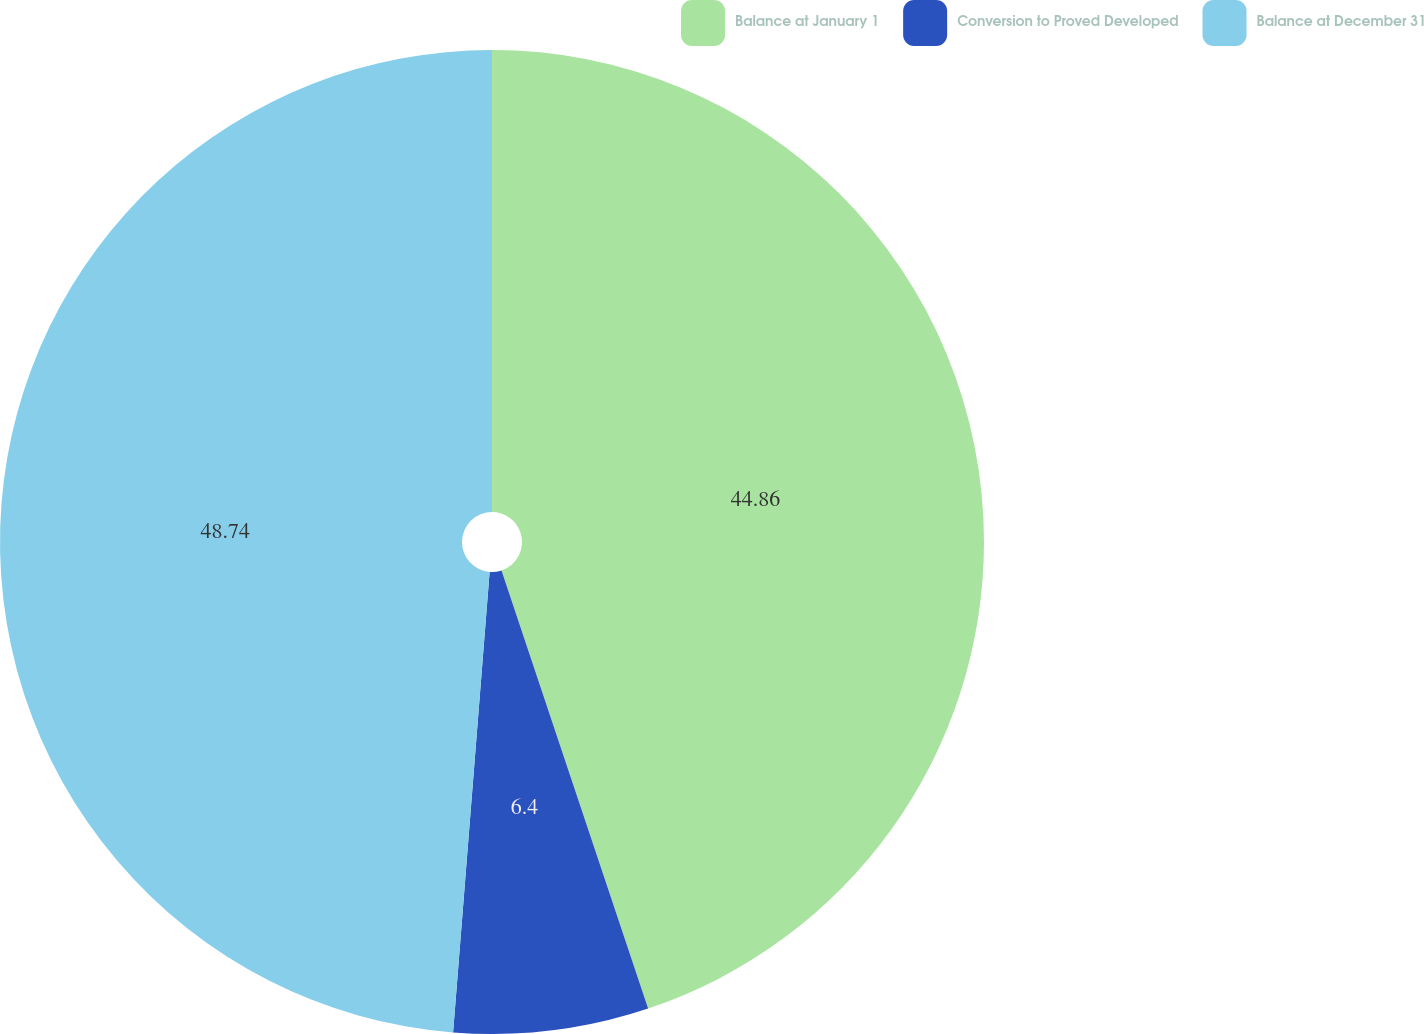Convert chart to OTSL. <chart><loc_0><loc_0><loc_500><loc_500><pie_chart><fcel>Balance at January 1<fcel>Conversion to Proved Developed<fcel>Balance at December 31<nl><fcel>44.86%<fcel>6.4%<fcel>48.74%<nl></chart> 